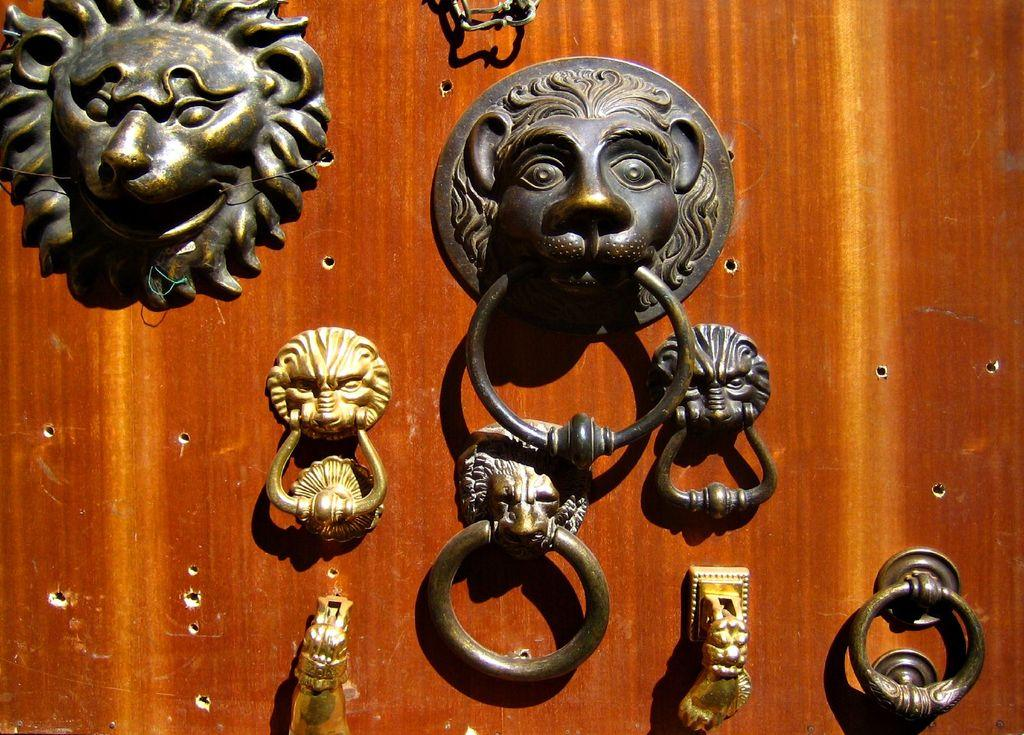What type of objects can be seen on the wooden surface in the image? There are metal objects on a wooden surface in the image. Can you describe these metal objects in more detail? Yes, the metal objects are door knockers. How many cattle can be seen grazing in the image? There are no cattle present in the image; it features door knockers on a wooden surface. What type of material is the rule made of in the image? There is no rule present in the image. 